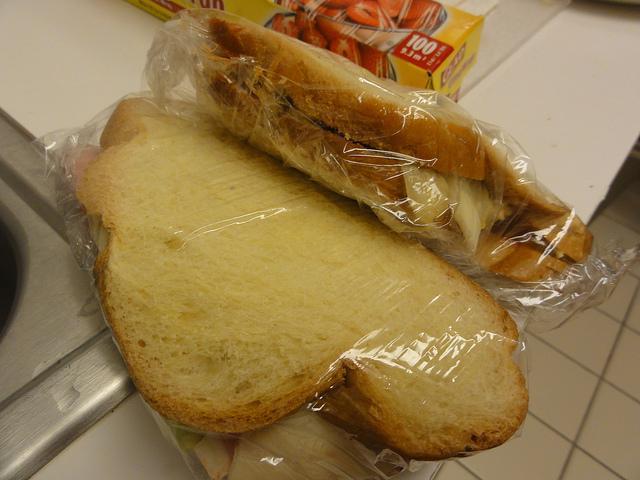How many sandwiches can you see?
Give a very brief answer. 2. How many people are wearing a black shirt?
Give a very brief answer. 0. 